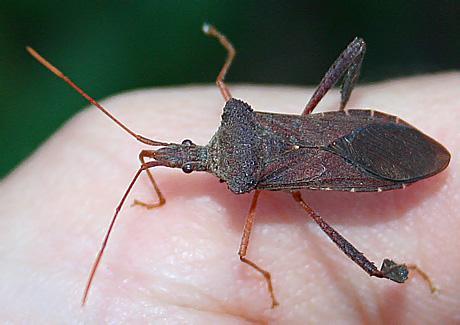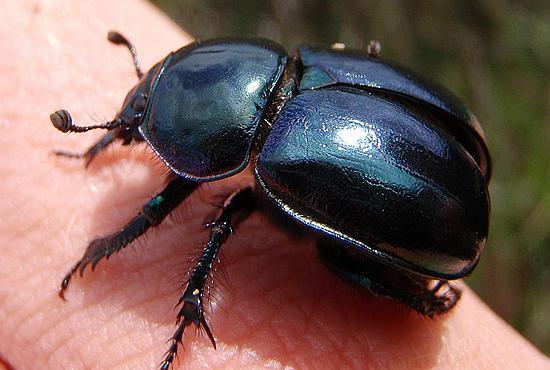The first image is the image on the left, the second image is the image on the right. For the images displayed, is the sentence "The insect in one of the images is standing upon a green leaf." factually correct? Answer yes or no. No. 